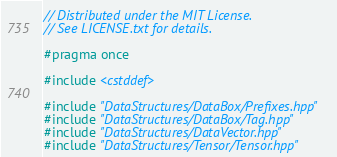Convert code to text. <code><loc_0><loc_0><loc_500><loc_500><_C++_>// Distributed under the MIT License.
// See LICENSE.txt for details.

#pragma once

#include <cstddef>

#include "DataStructures/DataBox/Prefixes.hpp"
#include "DataStructures/DataBox/Tag.hpp"
#include "DataStructures/DataVector.hpp"
#include "DataStructures/Tensor/Tensor.hpp"</code> 